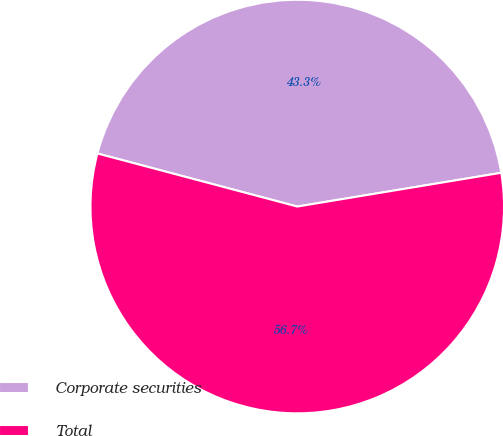Convert chart to OTSL. <chart><loc_0><loc_0><loc_500><loc_500><pie_chart><fcel>Corporate securities<fcel>Total<nl><fcel>43.26%<fcel>56.74%<nl></chart> 